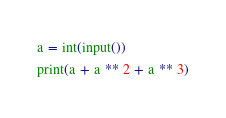Convert code to text. <code><loc_0><loc_0><loc_500><loc_500><_Python_>a = int(input())
print(a + a ** 2 + a ** 3)</code> 